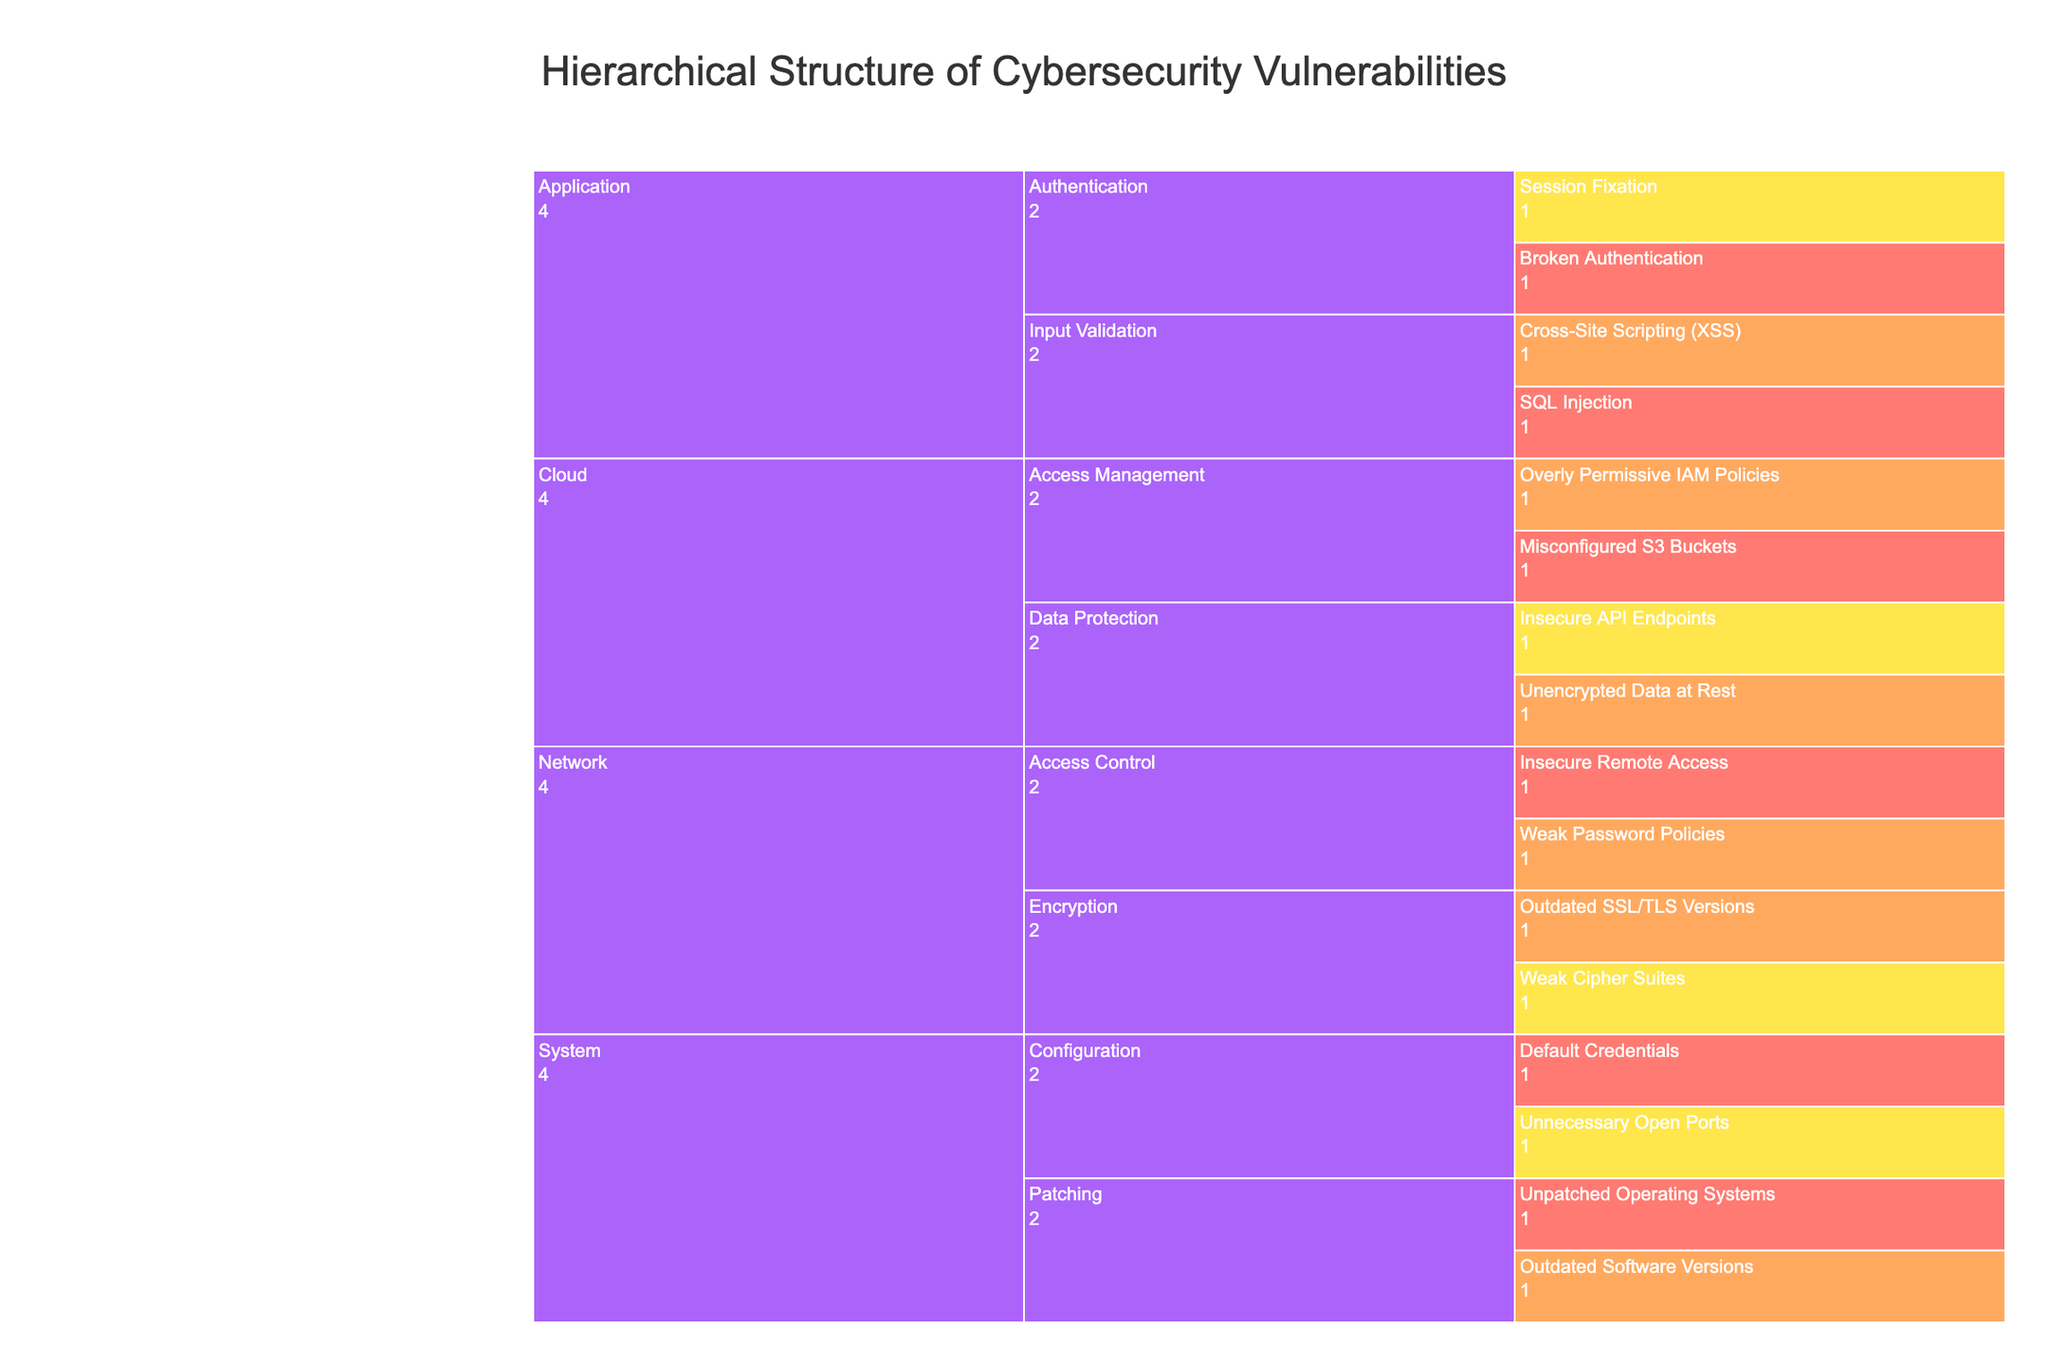What is the title of the Icicle Chart? The title is displayed at the top of the icicle chart. It provides a summary of the information contained in the chart. In this case, the title is "Hierarchical Structure of Cybersecurity Vulnerabilities".
Answer: Hierarchical Structure of Cybersecurity Vulnerabilities How many categories are there in the chart? The chart shows the main categories of cybersecurity vulnerabilities. In this case, the categories are the primary branches of the icicle chart. By counting the main branches, we can determine the number of categories.
Answer: Four Which category has the most vulnerabilities? To determine which category has the most vulnerabilities, we need to count the number of vulnerabilities listed under each main category. The category with the highest count is the one with the most vulnerabilities.
Answer: System Which severity level appears most frequently in the Network category? To find this, we need to look at the Network category and count the occurrences of each severity level. The severity level that appears the most frequently is the one we are looking for.
Answer: High Which specific vulnerability is labeled as Critical under the Application category? We need to look under the Application category and identify which vulnerabilities are marked with "Critical" severity. There are several, but in this case, specifically identify the one relevant to the question.
Answer: SQL Injection How do vulnerabilities in the Cloud category compare in terms of severity levels? To answer this, we have to analyze the severity levels of vulnerabilities listed under the Cloud category and compare their frequencies. This will involve looking at each vulnerability and noting down its severity to form a comparison.
Answer: Mostly High and Critical What is the most common subcategory of vulnerabilities in the Application category? We look at the Application category to see which subcategories are listed. Then we count the occurrences of each subcategory. The subcategory with the highest frequency is the most common one.
Answer: Input Validation How many vulnerabilities are labeled as Medium severity? We need to count all the vulnerabilities across all categories that are labeled with "Medium" severity. This will provide the total number of medium severity vulnerabilities.
Answer: Four In the System category, what are the vulnerabilities related to Patching? Look under the System category and find the subcategory labeled "Patching". Then list the vulnerabilities that fall under this subcategory.
Answer: Unpatched Operating Systems, Outdated Software Versions Which category has no vulnerabilities listed as Medium severity? To find this category, we examine each category and check the severity levels of the vulnerabilities within them. The category without any Medium severity vulnerabilities is the answer.
Answer: Application 